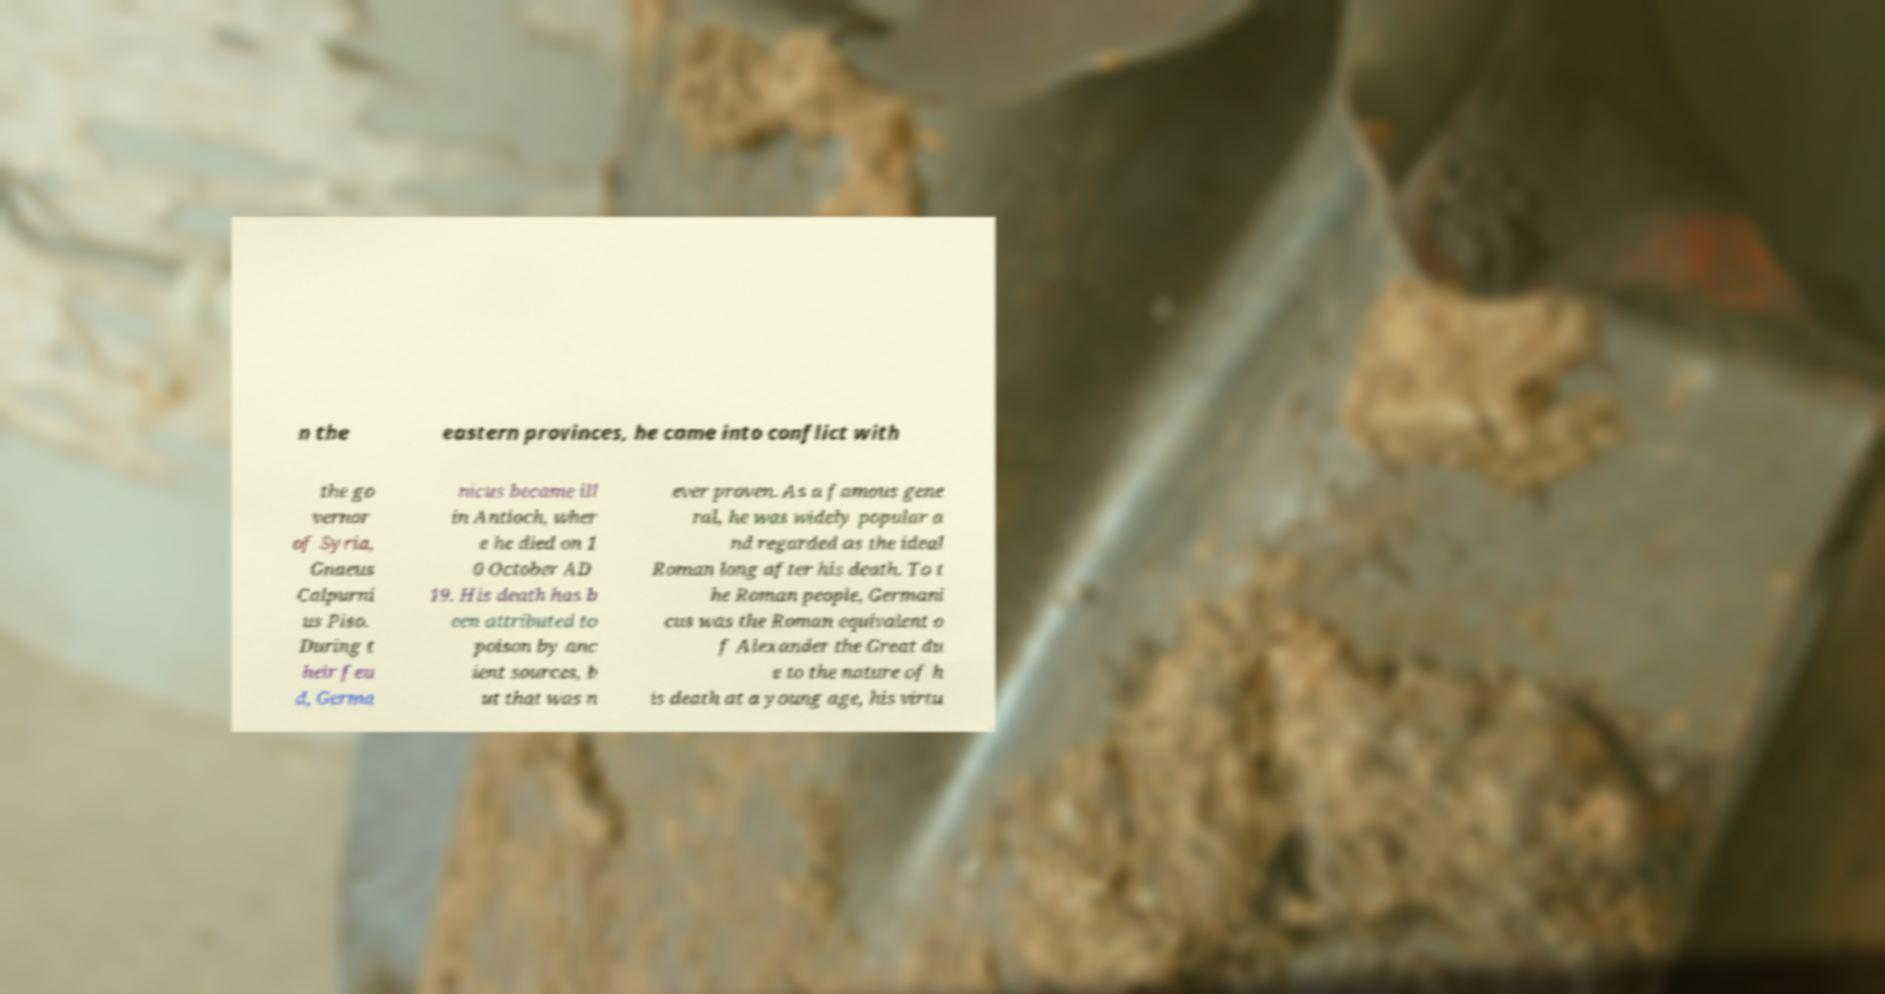Please identify and transcribe the text found in this image. n the eastern provinces, he came into conflict with the go vernor of Syria, Gnaeus Calpurni us Piso. During t heir feu d, Germa nicus became ill in Antioch, wher e he died on 1 0 October AD 19. His death has b een attributed to poison by anc ient sources, b ut that was n ever proven. As a famous gene ral, he was widely popular a nd regarded as the ideal Roman long after his death. To t he Roman people, Germani cus was the Roman equivalent o f Alexander the Great du e to the nature of h is death at a young age, his virtu 